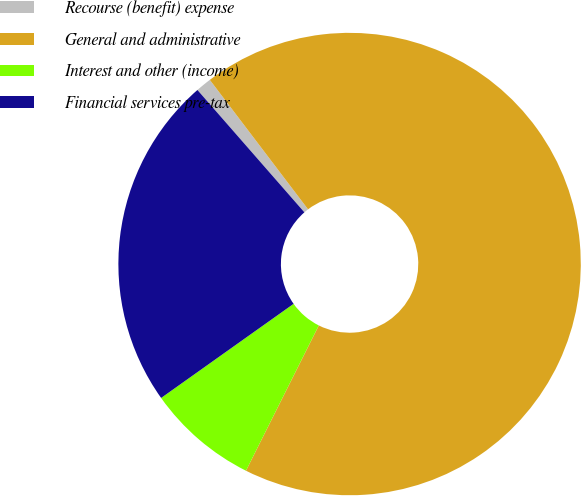Convert chart to OTSL. <chart><loc_0><loc_0><loc_500><loc_500><pie_chart><fcel>Recourse (benefit) expense<fcel>General and administrative<fcel>Interest and other (income)<fcel>Financial services pre-tax<nl><fcel>1.1%<fcel>67.73%<fcel>7.77%<fcel>23.4%<nl></chart> 